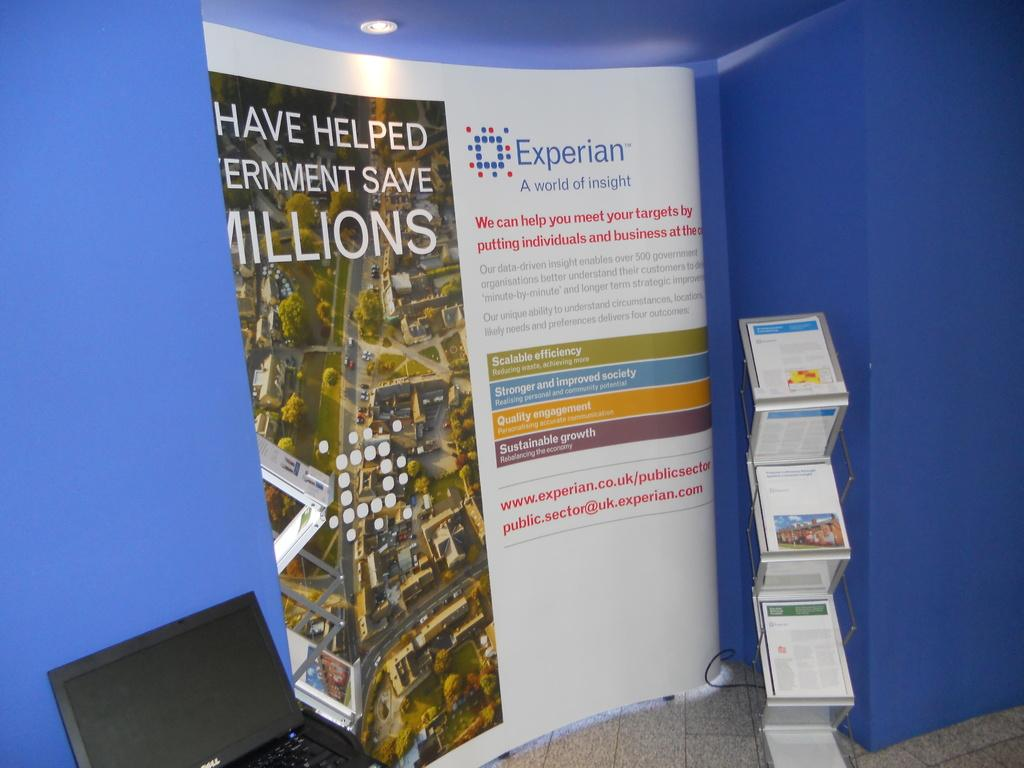Provide a one-sentence caption for the provided image. A display for Experian a world of insights and  laptop on the left . 